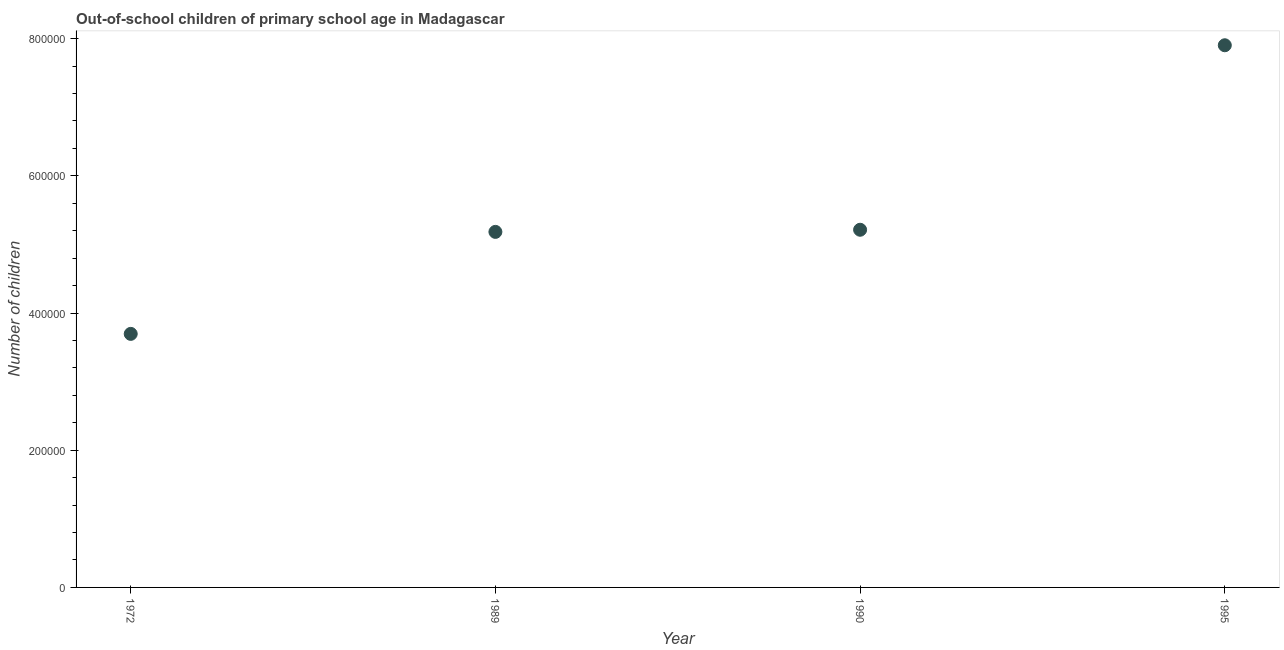What is the number of out-of-school children in 1972?
Make the answer very short. 3.70e+05. Across all years, what is the maximum number of out-of-school children?
Provide a succinct answer. 7.90e+05. Across all years, what is the minimum number of out-of-school children?
Keep it short and to the point. 3.70e+05. In which year was the number of out-of-school children minimum?
Offer a terse response. 1972. What is the sum of the number of out-of-school children?
Give a very brief answer. 2.20e+06. What is the difference between the number of out-of-school children in 1972 and 1989?
Keep it short and to the point. -1.49e+05. What is the average number of out-of-school children per year?
Ensure brevity in your answer.  5.50e+05. What is the median number of out-of-school children?
Ensure brevity in your answer.  5.20e+05. In how many years, is the number of out-of-school children greater than 560000 ?
Provide a succinct answer. 1. Do a majority of the years between 1990 and 1972 (inclusive) have number of out-of-school children greater than 200000 ?
Provide a succinct answer. No. What is the ratio of the number of out-of-school children in 1972 to that in 1989?
Offer a terse response. 0.71. Is the number of out-of-school children in 1990 less than that in 1995?
Your answer should be very brief. Yes. What is the difference between the highest and the second highest number of out-of-school children?
Provide a succinct answer. 2.69e+05. What is the difference between the highest and the lowest number of out-of-school children?
Provide a short and direct response. 4.21e+05. Does the number of out-of-school children monotonically increase over the years?
Your answer should be very brief. Yes. How many dotlines are there?
Give a very brief answer. 1. Does the graph contain any zero values?
Offer a very short reply. No. Does the graph contain grids?
Your answer should be very brief. No. What is the title of the graph?
Your answer should be compact. Out-of-school children of primary school age in Madagascar. What is the label or title of the Y-axis?
Your answer should be very brief. Number of children. What is the Number of children in 1972?
Your answer should be compact. 3.70e+05. What is the Number of children in 1989?
Your response must be concise. 5.18e+05. What is the Number of children in 1990?
Keep it short and to the point. 5.21e+05. What is the Number of children in 1995?
Keep it short and to the point. 7.90e+05. What is the difference between the Number of children in 1972 and 1989?
Provide a succinct answer. -1.49e+05. What is the difference between the Number of children in 1972 and 1990?
Your response must be concise. -1.52e+05. What is the difference between the Number of children in 1972 and 1995?
Offer a terse response. -4.21e+05. What is the difference between the Number of children in 1989 and 1990?
Provide a short and direct response. -3106. What is the difference between the Number of children in 1989 and 1995?
Your response must be concise. -2.72e+05. What is the difference between the Number of children in 1990 and 1995?
Give a very brief answer. -2.69e+05. What is the ratio of the Number of children in 1972 to that in 1989?
Ensure brevity in your answer.  0.71. What is the ratio of the Number of children in 1972 to that in 1990?
Offer a very short reply. 0.71. What is the ratio of the Number of children in 1972 to that in 1995?
Make the answer very short. 0.47. What is the ratio of the Number of children in 1989 to that in 1995?
Make the answer very short. 0.66. What is the ratio of the Number of children in 1990 to that in 1995?
Make the answer very short. 0.66. 